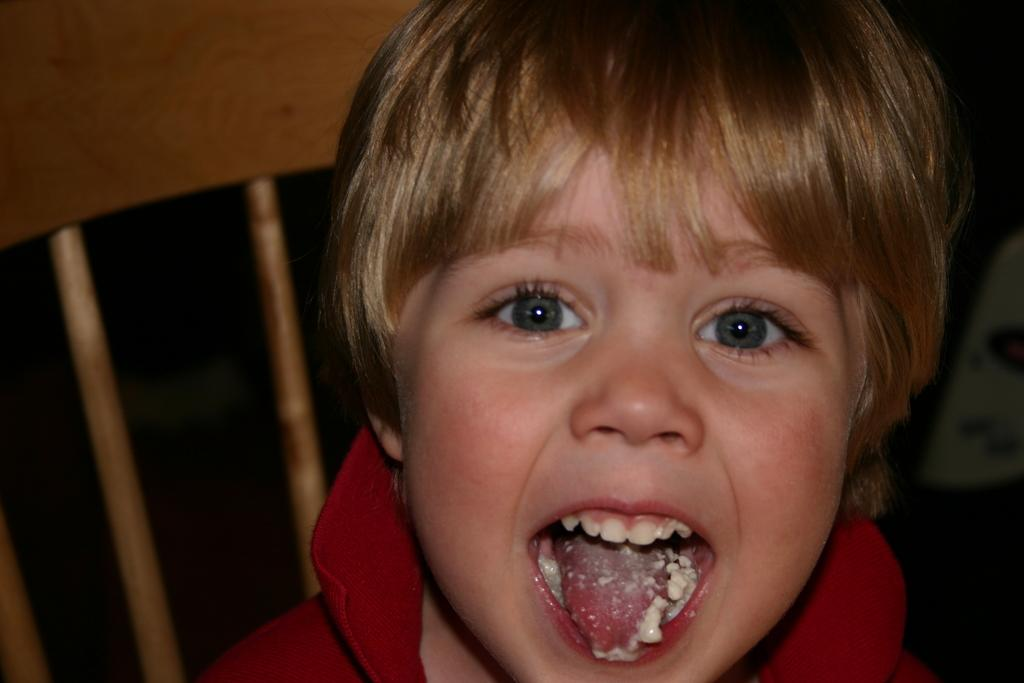Who is the main subject in the image? There is a boy in the image. Where is the boy located in the image? The boy is in the middle of the image. What is the boy doing in the image? The boy has opened his mouth. What can be seen behind the boy in the image? There appears to be a chair behind the boy. What is inside the boy's mouth? There is food in the boy's mouth. What scientific experiment is being conducted on the road in the image? There is no scientific experiment or road present in the image; it features a boy with food in his mouth. What type of sky is visible in the image? There is no sky visible in the image; it is focused on the boy and the chair behind him. 